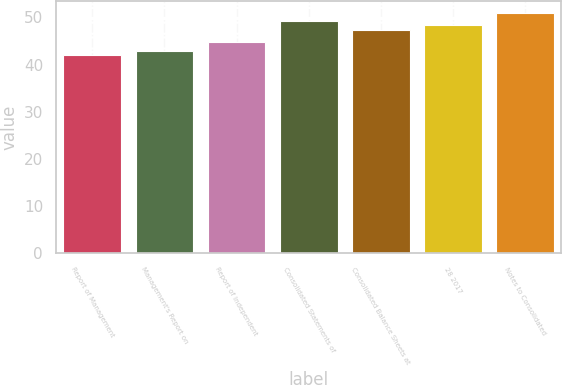Convert chart. <chart><loc_0><loc_0><loc_500><loc_500><bar_chart><fcel>Report of Management<fcel>Management's Report on<fcel>Report of Independent<fcel>Consolidated Statements of<fcel>Consolidated Balance Sheets at<fcel>28 2017<fcel>Notes to Consolidated<nl><fcel>42<fcel>42.9<fcel>44.7<fcel>49.2<fcel>47.4<fcel>48.3<fcel>51<nl></chart> 